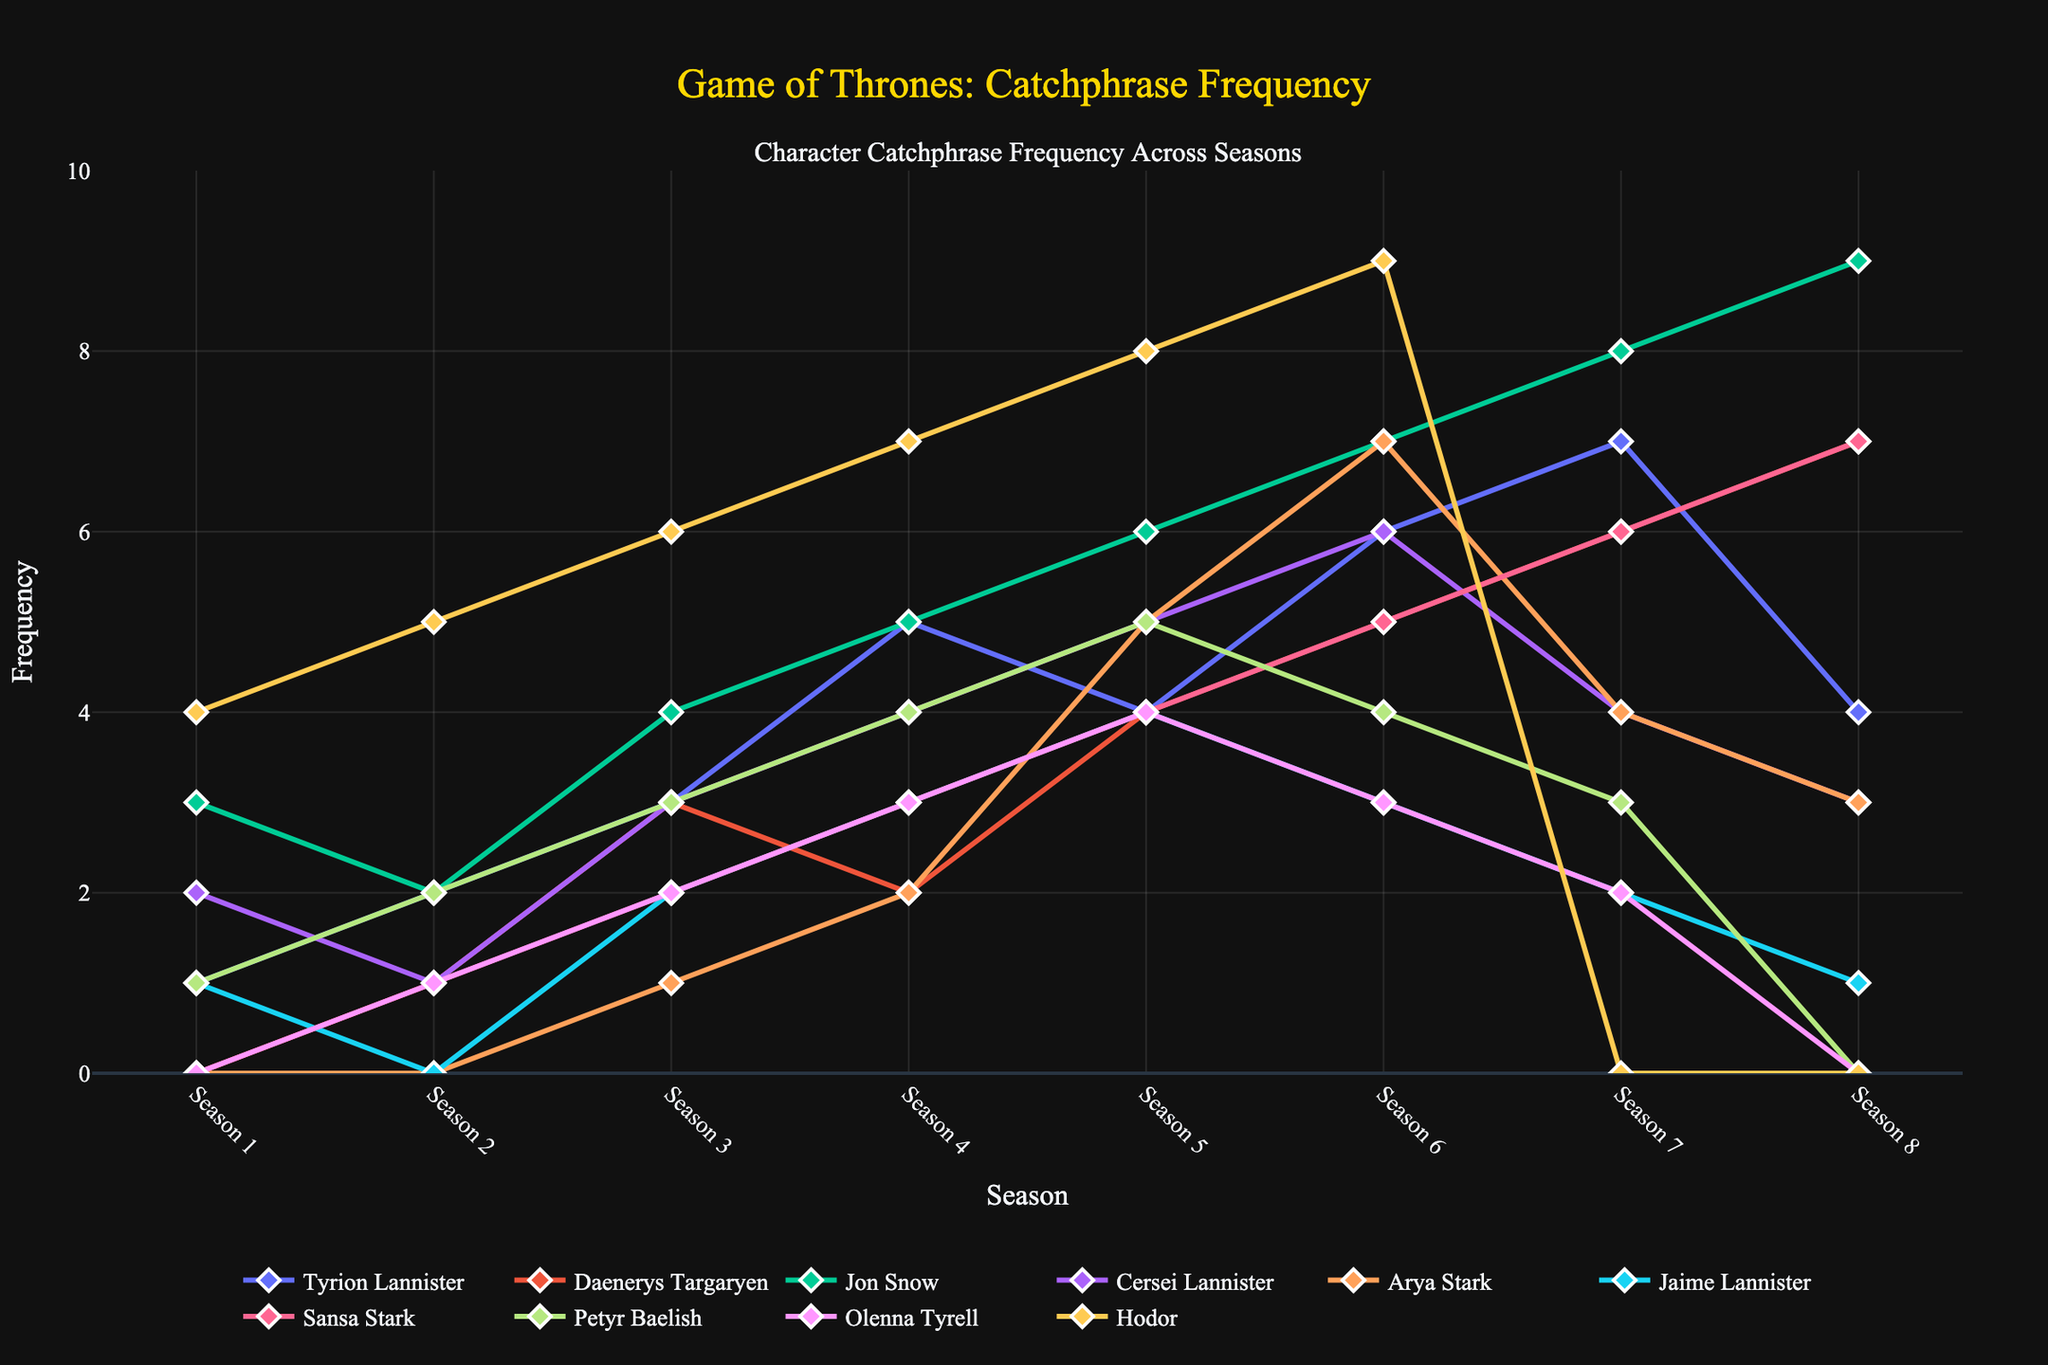What is the most frequently used catchphrase by any character in any single season? To answer this, we need to look at all the catchphrases across the seasons and find the highest frequency. Examining the figure, we see Hodor's catchphrase "Hodor" peaks at season 6 and 7 with a frequency of 9, the highest in any single season.
Answer: 9 (Hodor in Season 6 and 7) Which character showed the greatest increase in the frequency of their catchphrase from Season 1 to Season 8? To find this, we need to calculate the increase from Season 1 to Season 8 for each character and compare them. Jon Snow’s catchphrase increased the most from 3 to 9, an increase of 6 times.
Answer: Jon Snow (increased by 6) Which two characters have the same number of catchphrase occurrences in any season? By examining the plotted lines on the figure, we can see that Daenerys Targaryen and Sansa Stark both have a frequency of 7 in Season 7.
Answer: Daenerys Targaryen and Sansa Stark (7 in Season 7) In which season did Arya Stark first use her catchphrase? We need to identify the first non-zero occurrence of Arya Stark's catchphrase. The figure shows that her catchphrase, "A girl has no name," first appears in Season 3 with a frequency of 1.
Answer: Season 3 Which character's catchphrase peaks in Season 5? By looking for the highest peak in Season 5, we see that Hodor's catchphrase peaks with a frequency of 8.
Answer: Hodor Compare Cersei Lannister and Jaime Lannister’s catchphrases. Who had a higher frequency in Season 4? We observe the respective points in Season 4 for both characters. Cersei Lannister has a frequency of 4 while Jaime Lannister has a frequency of 3.
Answer: Cersei Lannister What is the average frequency of Tyrion Lannister’s catchphrase across all the seasons? We sum up the frequencies of Tyrion Lannister’s catchphrase (1 + 2 + 3 + 5 + 4 + 6 + 7 + 4 = 32) and divide it by the number of seasons (32 / 8 = 4).
Answer: 4 Between Daenerys Targaryen and Arya Stark, whose catchphrase sees a consistent increase without any decline? By reviewing both lines for constant upward trends, Daenerys Targaryen shows a steady increase without any dips across all seasons. Arya Stark’s catchphrase, while generally increasing, does have varying frequencies.
Answer: Daenerys Targaryen Did Petyr Baelish’s catchphrase increase or decrease in the final season compared to the previous one? In Season 7, Petyr Baelish’s catchphrase frequency is 3, and in Season 8, it drops to 0. This indicates a decrease.
Answer: Decrease Which character's catchphrase experienced the largest single-season drop and between which seasons did this occur? By comparing the frequency drops between seasons for each character, Hodor's catchphrase drops from 9 in Season 6 to 0 in Season 7, the largest drop of 9.
Answer: Hodor (from Season 6 to 7, drop of 9) 